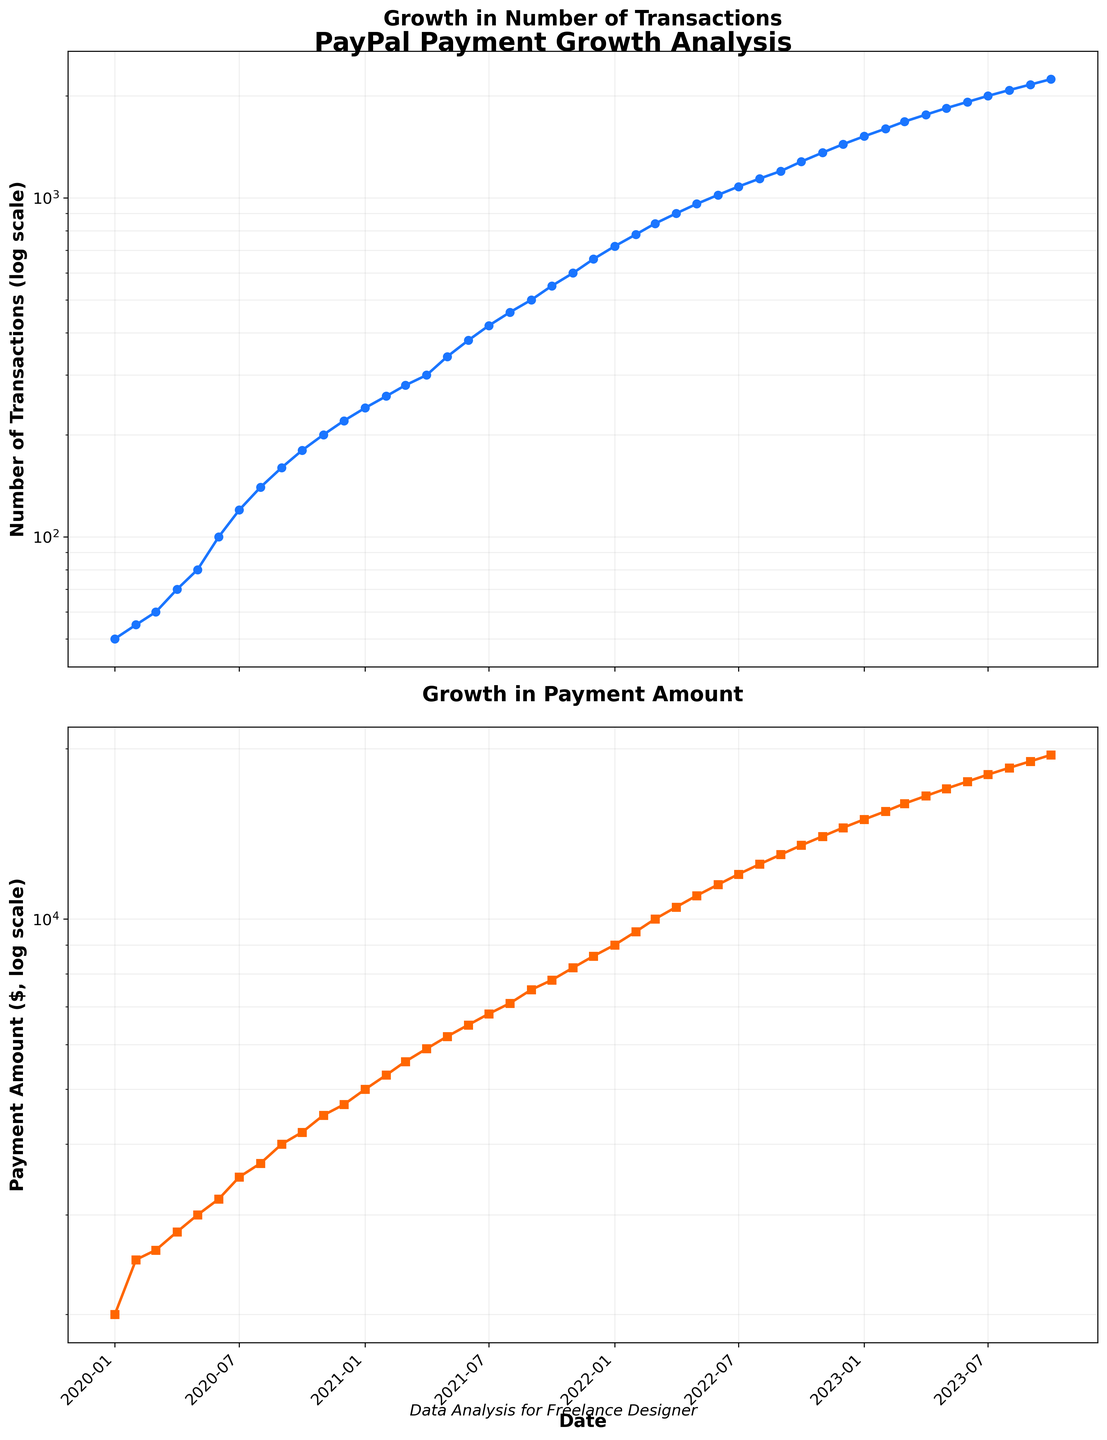What is the title of the entire figure? The title of the entire figure can be found at the top of the figure, usually in a larger and bold font. It provides the context of the data presented in the plots.
Answer: PayPal Payment Growth Analysis How many subplots are in the figure? The number of subplots can be counted by visually identifying the separate chart areas within the figure.
Answer: 2 What are the titles of the two subplots? The titles of the subplots are usually found above each individual plot and describe the specific aspect of the data being visualized in that subplot.
Answer: Growth in Number of Transactions; Growth in Payment Amount What axis is shared between the two subplots? The shared axis is often labeled the same and has consistent markers across the subplots.
Answer: Date (X-axis) What kind of scale is used for the Y-axes in both subplots? The type of scale can be identified by observing the labels and the way the data points are distributed. In this case, the logarithmic scale is indicated by the unequal spacing of tick marks and the presence of a "log scale" label.
Answer: Logarithmic What is the trend in the number of transactions over time? The trend can be described by observing the overall direction of the dataset plotted over time.
Answer: Increasing When did the number of transactions reach 1000? Locate the point where the plot for the number of transactions reaches the 1000 mark, and then identify the corresponding date.
Answer: 2022-06 Which subplot shows a higher rate of growth, the number of transactions or the payment amounts? Compare the slopes of the lines in both subplots. A steeper slope indicates a higher rate of growth.
Answer: Number of Transactions How much did the payment amount increase from January 2020 to January 2023? To find the increase, identify the payment amounts at these two points and subtract the January 2020 value from the January 2023 value.
Answer: $13,000 What is the average number of transactions from January 2020 to October 2023? Sum all the values of transactions during the given period and divide by the total number of data points. In this case, there are 46 data points.
Answer: (50 + 55 + ... + 2160 + 2240) / 46 ≈ 923 